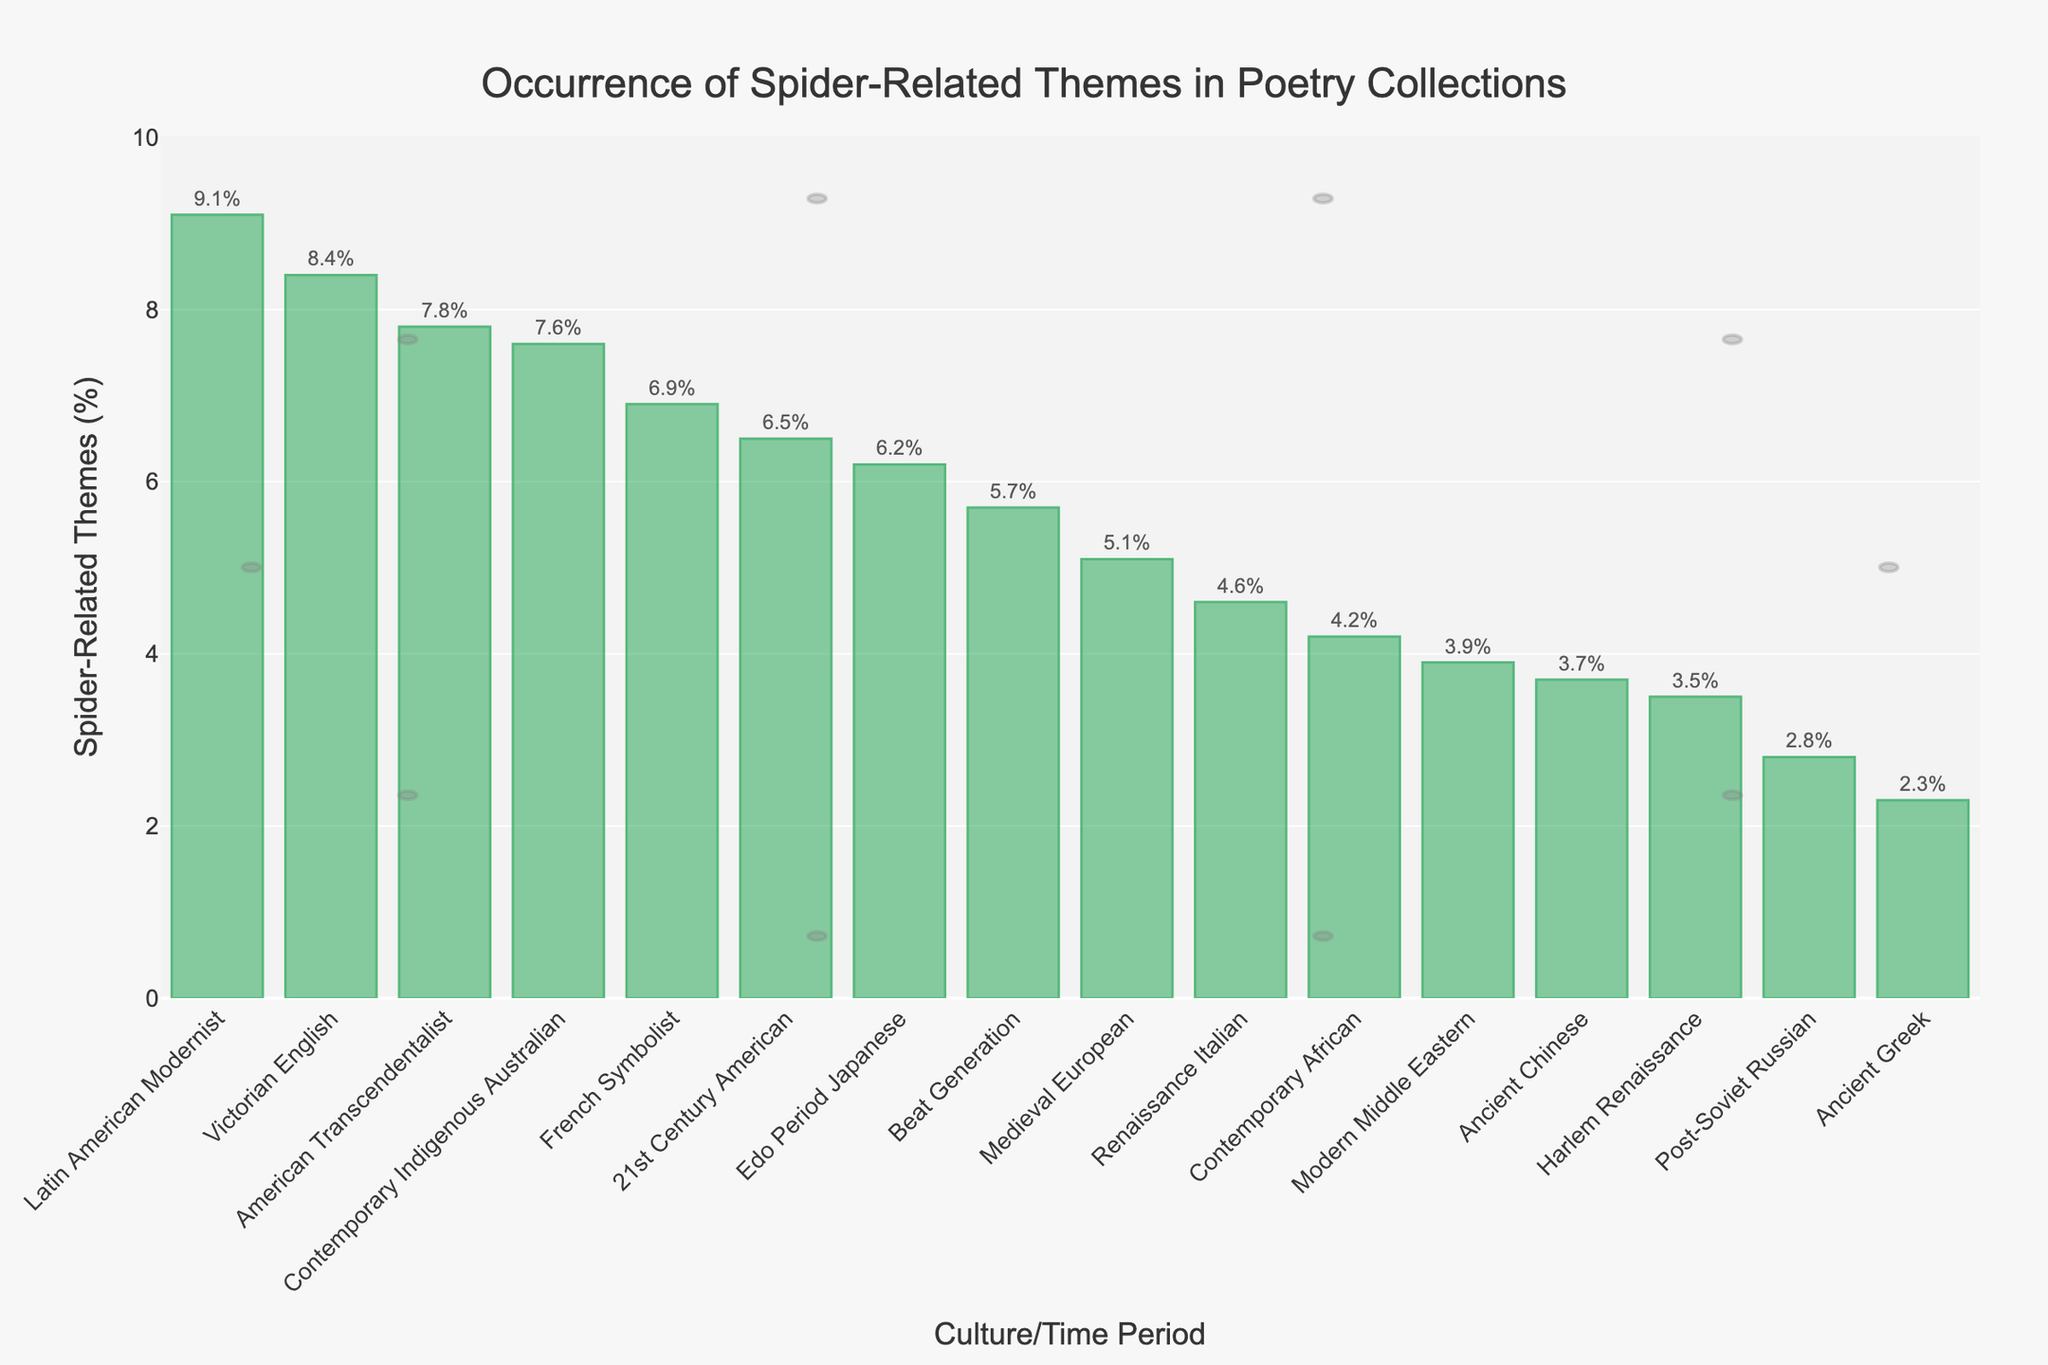Which culture/time period has the highest occurrence of spider-related themes? Look at the bar with the greatest height. The Latin American Modernist period has the highest bar, indicating it has the highest occurrence.
Answer: Latin American Modernist What is the average occurrence of spider-related themes across all cultures/time periods? Sum all percentages: 2.3 + 3.7 + 5.1 + 4.6 + 6.2 + 8.4 + 7.8 + 6.9 + 3.5 + 9.1 + 5.7 + 4.2 + 3.9 + 2.8 + 7.6 + 6.5 = 88.3. There are 16 periods. Average = 88.3 / 16.
Answer: 5.52 Which culture/time period has the lowest occurrence of spider-related themes? Look at the bar with the smallest height. The Ancient Greek period has the smallest bar, indicating the lowest occurrence.
Answer: Ancient Greek How much higher is the occurrence of spider-related themes in Victorian English poetry compared to Ancient Greek poetry? Subtract the percentage of Ancient Greek (2.3) from Victorian English (8.4): 8.4 - 2.3 = 6.1
Answer: 6.1 Which culture/time periods have more than 6% occurrence of spider-related themes? Identify the bars above the 6% mark: Edo Period Japanese (6.2), Victorian English (8.4), American Transcendentalist (7.8), French Symbolist (6.9), Latin American Modernist (9.1), Contemporary Indigenous Australian (7.6), 21st Century American (6.5).
Answer: Edo Period Japanese, Victorian English, American Transcendentalist, French Symbolist, Latin American Modernist, Contemporary Indigenous Australian, 21st Century American Is the occurrence of spider-related themes in Renaissance Italian poetry higher or lower than in Medieval European poetry? Compare the heights. Renaissance Italian (4.6) is lower than Medieval European (5.1).
Answer: Lower How does the occurrence of spider-related themes in Contemporary African poetry compare to Modern Middle Eastern poetry? Compare the heights. Contemporary African (4.2) is higher than Modern Middle Eastern (3.9).
Answer: Higher By how much does the occurrence of spider-related themes in Beat Generation poetry differ from Edo Period Japanese poetry? Subtract the percentage of Edo Period Japanese (6.2) from Beat Generation (5.7): 6.2 - 5.7 = 0.5
Answer: 0.5 What's the combined occurrence of spider-related themes in American Transcendentalist and French Symbolist poetry? Add the percentages of American Transcendentalist (7.8) and French Symbolist (6.9): 7.8 + 6.9 = 14.7
Answer: 14.7 